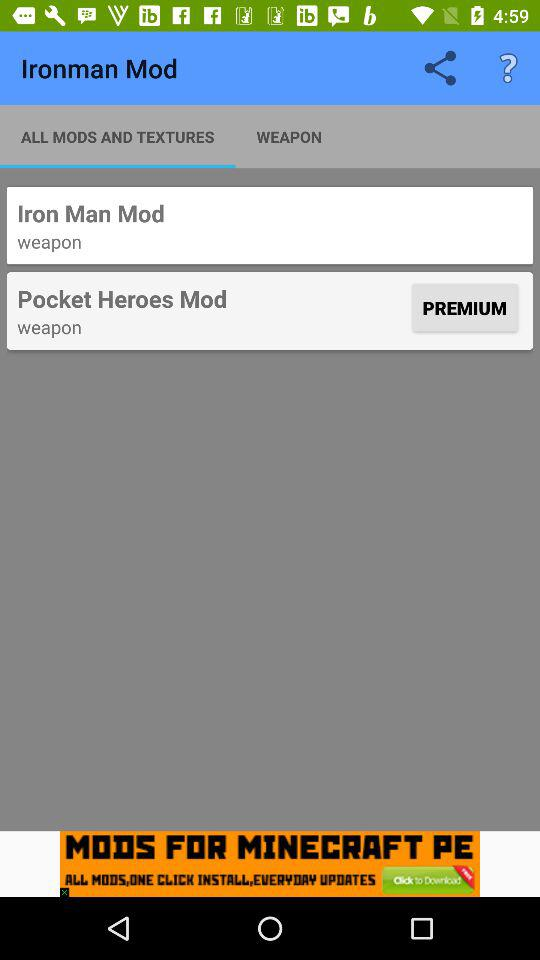Which tab is selected? The selected tab is "ALL MODS AND TEXTURES". 